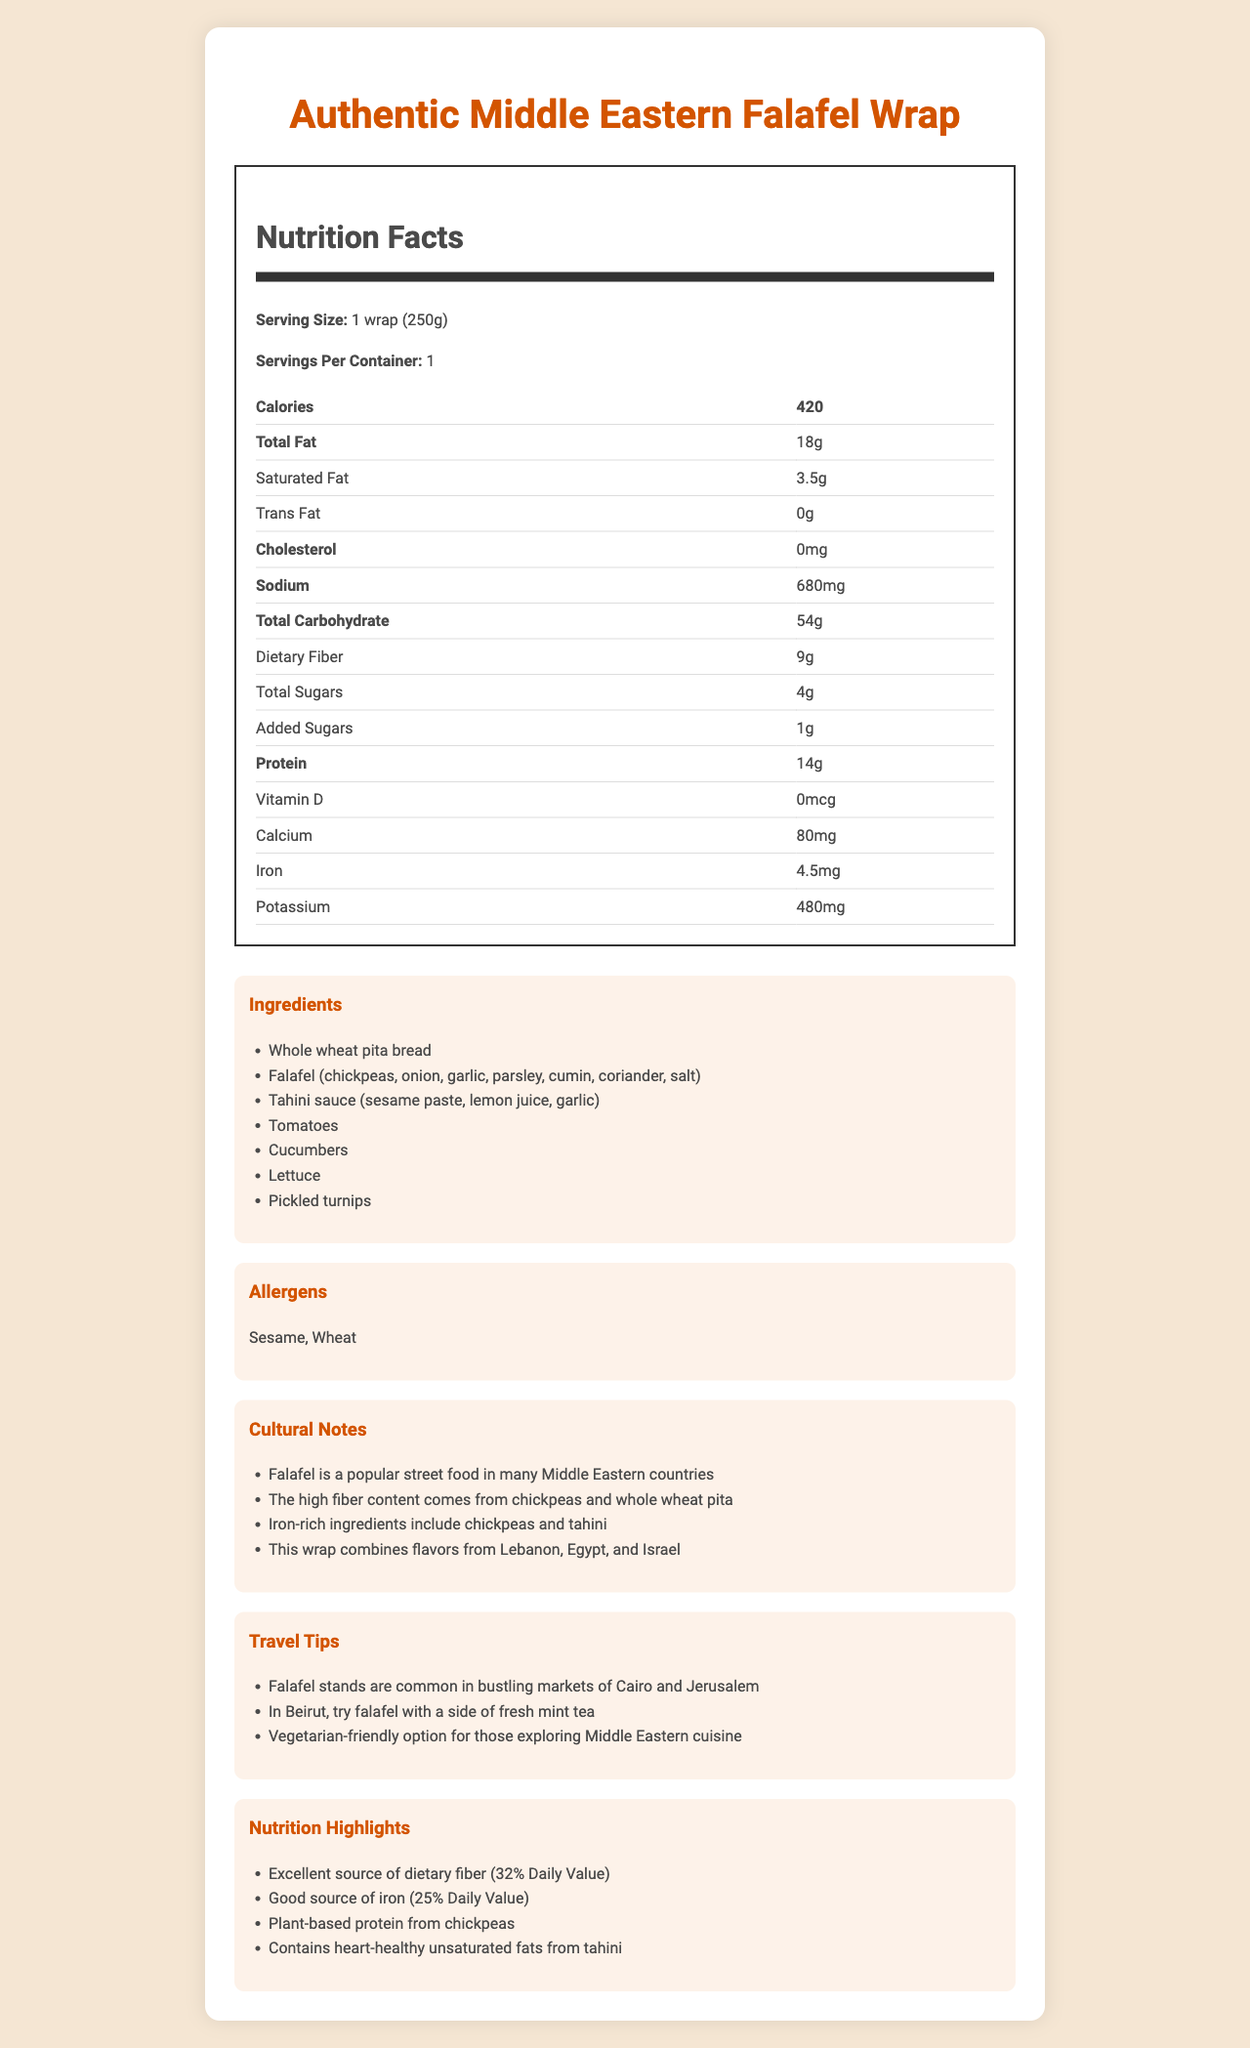what is the serving size of the Authentic Middle Eastern Falafel Wrap? The serving size is clearly listed under the Nutrition Facts section of the document.
Answer: 1 wrap (250g) how many calories does one wrap contain? The number of calories per serving is specified in the Nutrition Facts section.
Answer: 420 how much dietary fiber is in one serving of the falafel wrap? The dietary fiber content is listed in the table under Nutrition Facts.
Answer: 9g which ingredient contributes to the iron content in the falafel wrap? The Cultural Notes section mentions that chickpeas and tahini are iron-rich ingredients.
Answer: Chickpeas and tahini what is the percent Daily Value of dietary fiber provided by this falafel wrap? The Nutrition Highlights section states that this wrap is an excellent source of dietary fiber, providing 32% of the Daily Value.
Answer: 32% what is the sodium content of the falafel wrap? The sodium content is listed in the table under Nutrition Facts.
Answer: 680mg What Middle Eastern countries contribute to the flavors of this falafel wrap? The Cultural Notes section mentions the wrap combines flavors from Lebanon, Egypt, and Israel.
Answer: Lebanon, Egypt, and Israel How much protein is in one serving of the falafel wrap? The protein content is listed in the table under Nutrition Facts.
Answer: 14g what should you try in Beirut with your falafel wrap according to the travel tips? The Travel Tips section suggests trying falafel with a side of fresh mint tea in Beirut.
Answer: Fresh mint tea which one of the following allergens is present in the falafel wrap? A. Peanuts B. Dairy C. Wheat The Allergens section lists sesame and wheat as allergens present in the falafel wrap.
Answer: C. Wheat which ingredient is not a part of the falafel? A. Chickpeas B. Onions C. Pickled turnips Pickled turnips are not part of the falafel but are listed as one of the wrap ingredients.
Answer: C. Pickled turnips does the falafel wrap contain trans fat? According to the Nutrition Facts, the Trans Fat value is listed as 0g.
Answer: No describe the main nutritional and cultural highlights of the falafel wrap. This summary integrates both nutritional and cultural aspects highlighted in the document.
Answer: The falafel wrap is a rich source of dietary fiber and iron, mostly due to its chickpea and tahini content. It contains plant-based protein and heart-healthy unsaturated fats. Culturally, it incorporates flavors from Lebanon, Egypt, and Israel, and is a popular street food in many Middle Eastern countries. how many grams of total carbohydrates are in the falafel wrap? The total carbohydrate content is listed in the Nutrition Facts table as 54 grams.
Answer: 54g is this falafel wrap a good option for vegetarians? The Travel Tips section specifically mentions that the falafel wrap is a vegetarian-friendly option.
Answer: Yes how many added sugars does the falafel wrap have? The added sugars content is listed in the Nutrition Facts table.
Answer: 1g what is the primary component of tahini sauce in the falafel wrap? The ingredients list specifies that tahini sauce is made from sesame paste, lemon juice, and garlic.
Answer: Sesame paste can I determine the vitamin C content of the falafel wrap from this document? The Nutrition Facts section does not provide information on vitamin C content.
Answer: Not enough information 